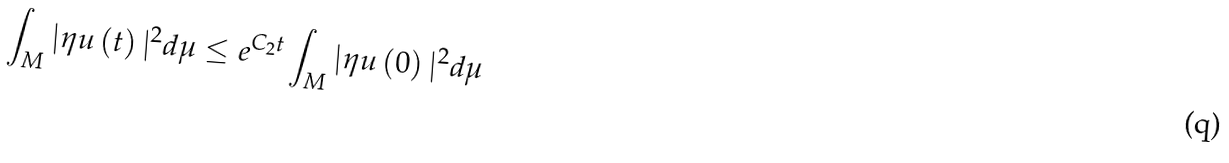<formula> <loc_0><loc_0><loc_500><loc_500>\int _ { M } | \eta u \left ( t \right ) | ^ { 2 } d \mu \leq e ^ { C _ { 2 } t } \int _ { M } | \eta u \left ( 0 \right ) | ^ { 2 } d \mu</formula> 